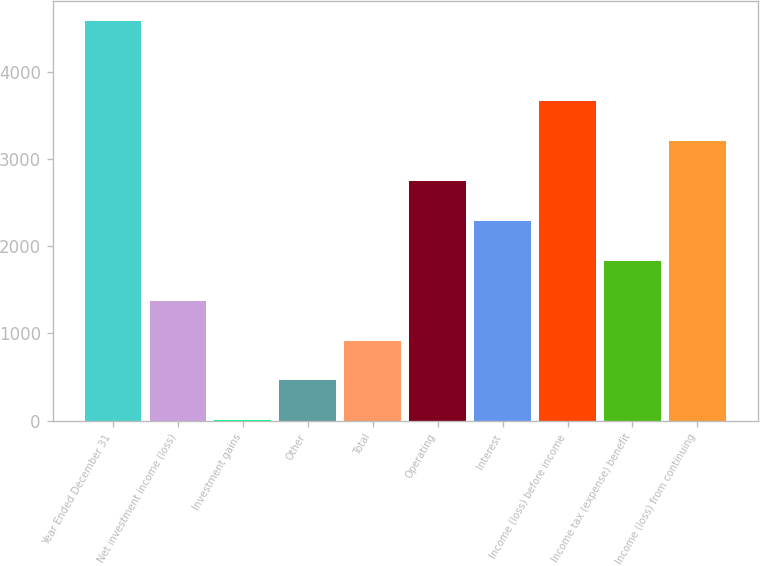Convert chart to OTSL. <chart><loc_0><loc_0><loc_500><loc_500><bar_chart><fcel>Year Ended December 31<fcel>Net investment income (loss)<fcel>Investment gains<fcel>Other<fcel>Total<fcel>Operating<fcel>Interest<fcel>Income (loss) before income<fcel>Income tax (expense) benefit<fcel>Income (loss) from continuing<nl><fcel>4587<fcel>1377.5<fcel>2<fcel>460.5<fcel>919<fcel>2753<fcel>2294.5<fcel>3670<fcel>1836<fcel>3211.5<nl></chart> 